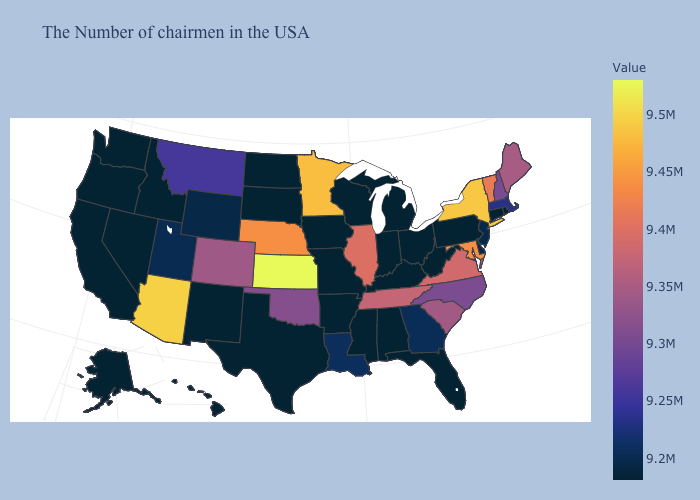Does Virginia have the highest value in the South?
Be succinct. No. Is the legend a continuous bar?
Give a very brief answer. Yes. Among the states that border Mississippi , does Tennessee have the highest value?
Concise answer only. Yes. 